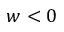Convert formula to latex. <formula><loc_0><loc_0><loc_500><loc_500>w < 0</formula> 